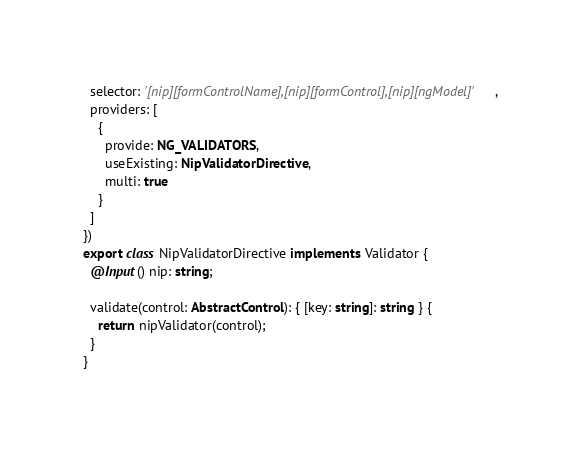Convert code to text. <code><loc_0><loc_0><loc_500><loc_500><_TypeScript_>  selector: '[nip][formControlName],[nip][formControl],[nip][ngModel]',
  providers: [
    {
      provide: NG_VALIDATORS,
      useExisting: NipValidatorDirective,
      multi: true
    }
  ]
})
export class NipValidatorDirective implements Validator {
  @Input() nip: string;

  validate(control: AbstractControl): { [key: string]: string } {
    return nipValidator(control);
  }
}
</code> 